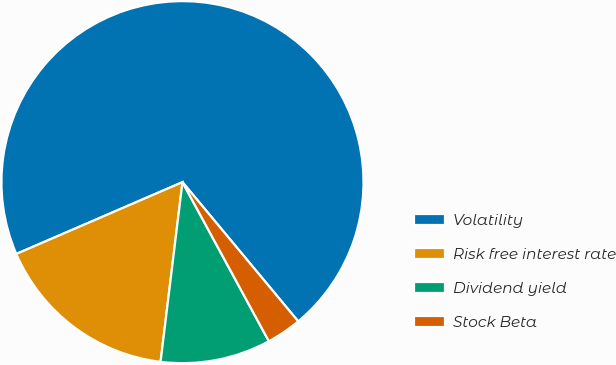<chart> <loc_0><loc_0><loc_500><loc_500><pie_chart><fcel>Volatility<fcel>Risk free interest rate<fcel>Dividend yield<fcel>Stock Beta<nl><fcel>70.46%<fcel>16.58%<fcel>9.85%<fcel>3.12%<nl></chart> 